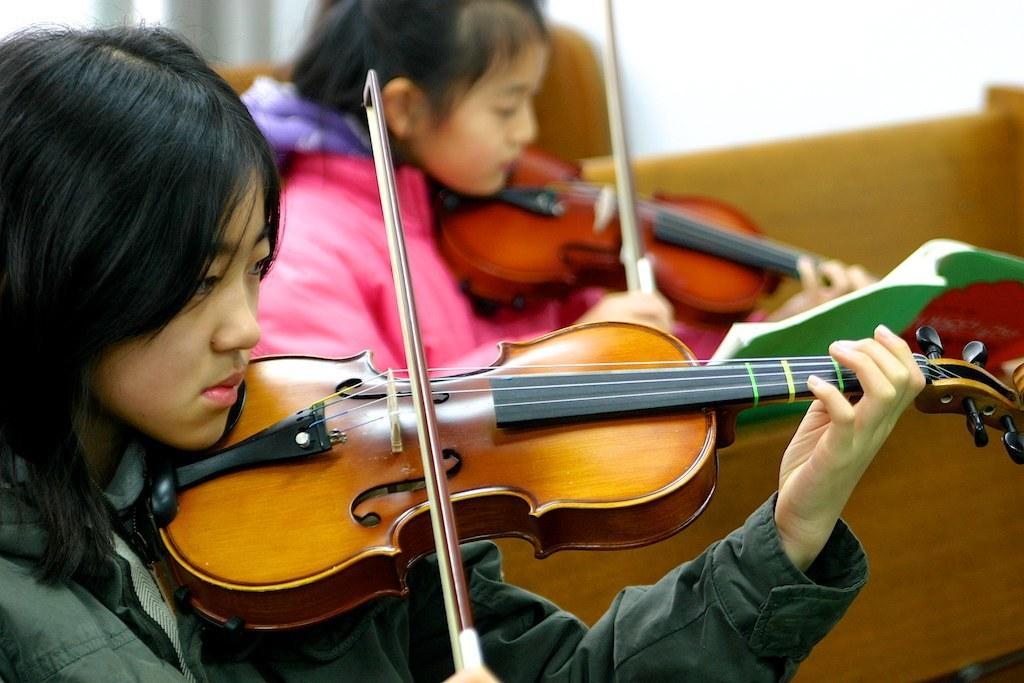In one or two sentences, can you explain what this image depicts? In this image there are 2 persons playing a musical instrument holding in their hands. 